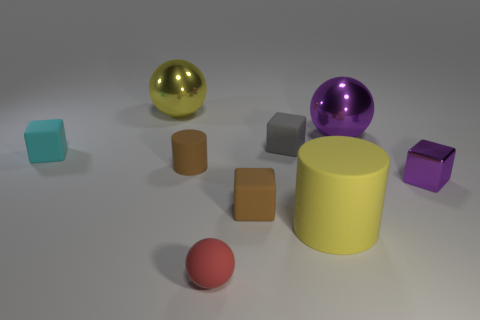Do the block in front of the small shiny thing and the cylinder to the left of the small gray thing have the same color?
Ensure brevity in your answer.  Yes. There is a object that is both on the left side of the tiny matte cylinder and in front of the large purple metal sphere; what material is it made of?
Make the answer very short. Rubber. There is a small brown cylinder that is to the left of the large yellow thing in front of the purple metal cube; what is it made of?
Provide a short and direct response. Rubber. Are there any other things of the same color as the big cylinder?
Your answer should be compact. Yes. The red object that is made of the same material as the large cylinder is what size?
Keep it short and to the point. Small. What number of big objects are blue rubber cylinders or rubber blocks?
Ensure brevity in your answer.  0. There is a shiny ball that is in front of the yellow thing that is behind the small purple shiny object in front of the small gray rubber thing; what size is it?
Make the answer very short. Large. How many balls have the same size as the cyan matte block?
Offer a terse response. 1. How many things are tiny cyan rubber objects or small rubber blocks to the right of the cyan rubber thing?
Provide a short and direct response. 3. What is the shape of the red object?
Give a very brief answer. Sphere. 